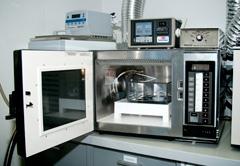What is the piping material being used for?
Quick response, please. Ventilation. Can I use this to cook my hot pocket?
Concise answer only. No. What sort of work environment would you call this?
Concise answer only. Lab. 